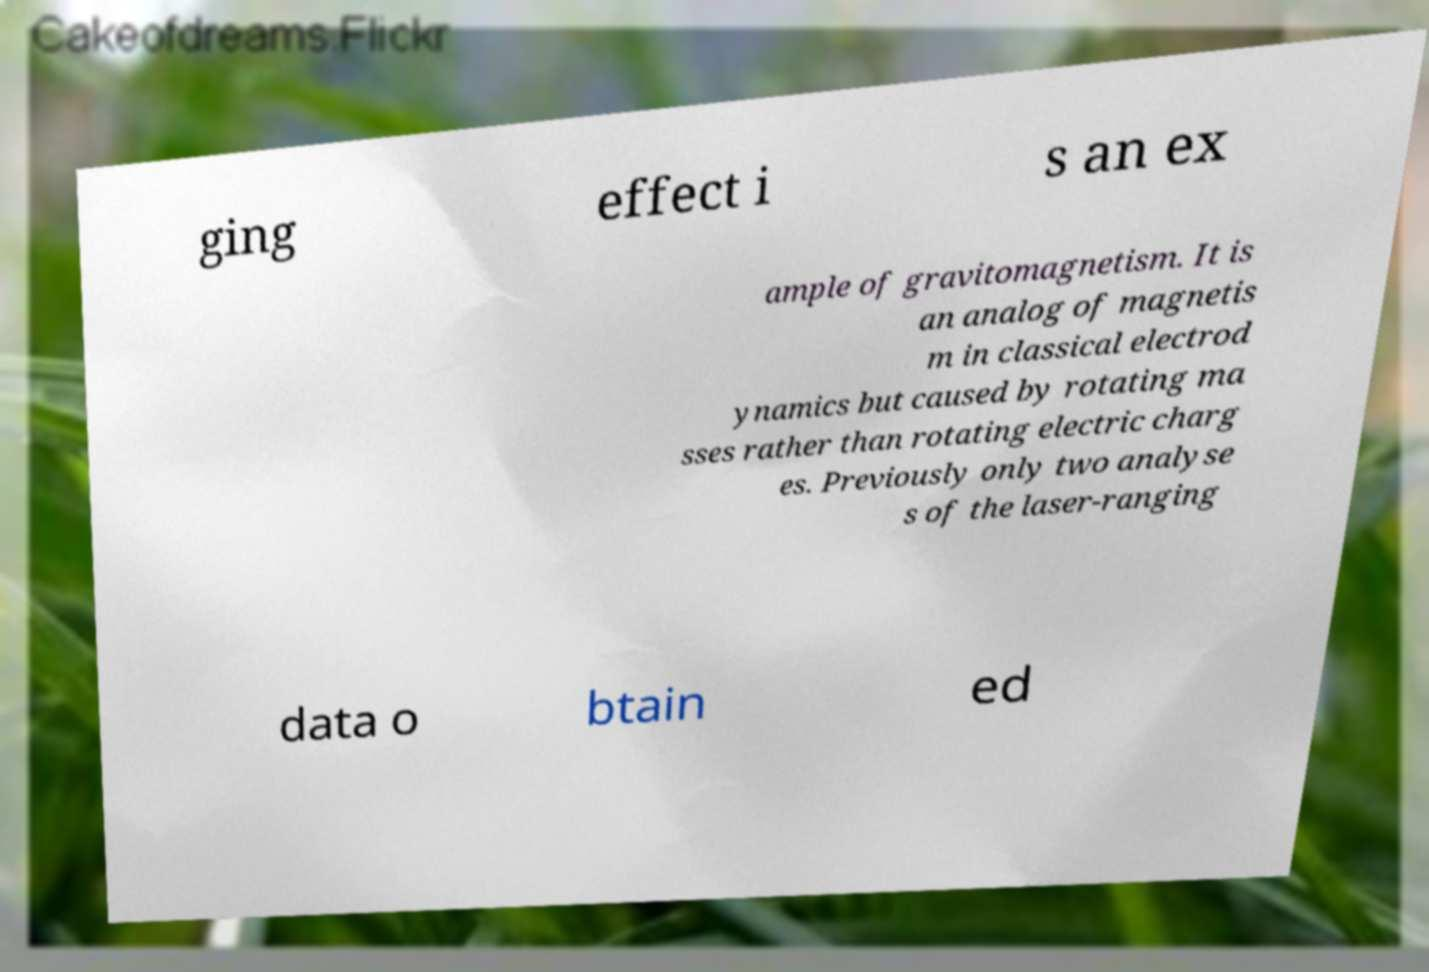Please identify and transcribe the text found in this image. ging effect i s an ex ample of gravitomagnetism. It is an analog of magnetis m in classical electrod ynamics but caused by rotating ma sses rather than rotating electric charg es. Previously only two analyse s of the laser-ranging data o btain ed 